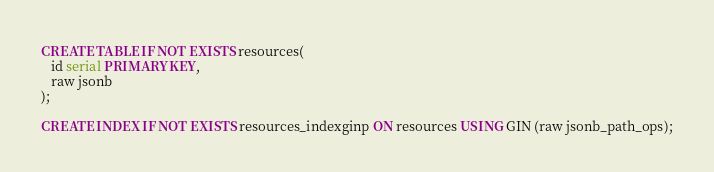<code> <loc_0><loc_0><loc_500><loc_500><_SQL_>CREATE TABLE IF NOT EXISTS resources(
   id serial PRIMARY KEY,
   raw jsonb
);

CREATE INDEX IF NOT EXISTS resources_indexginp ON resources USING GIN (raw jsonb_path_ops);
</code> 